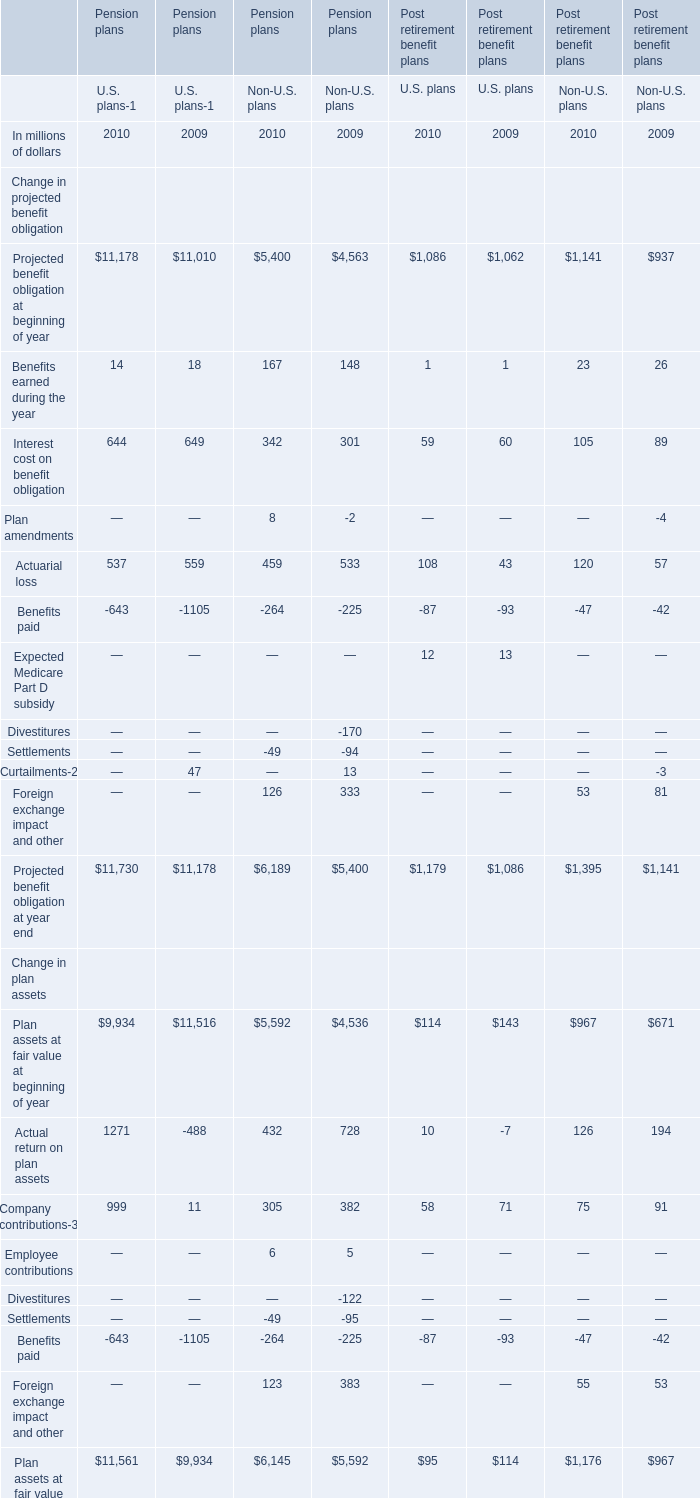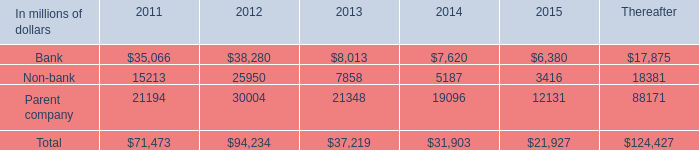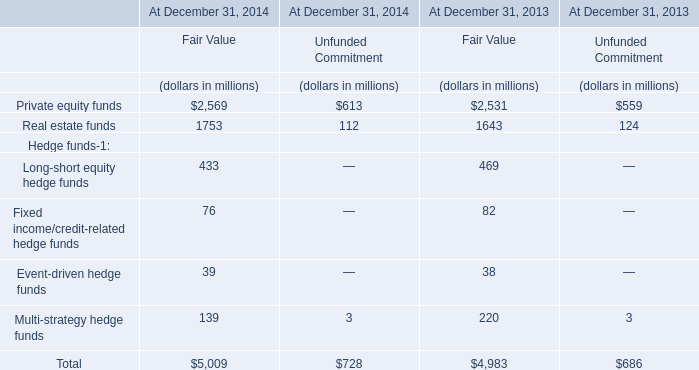What was the sum of Projected benefit obligation at beginning of year without those elements smaller than 10000, in 2010? (in million) 
Answer: 11178. 